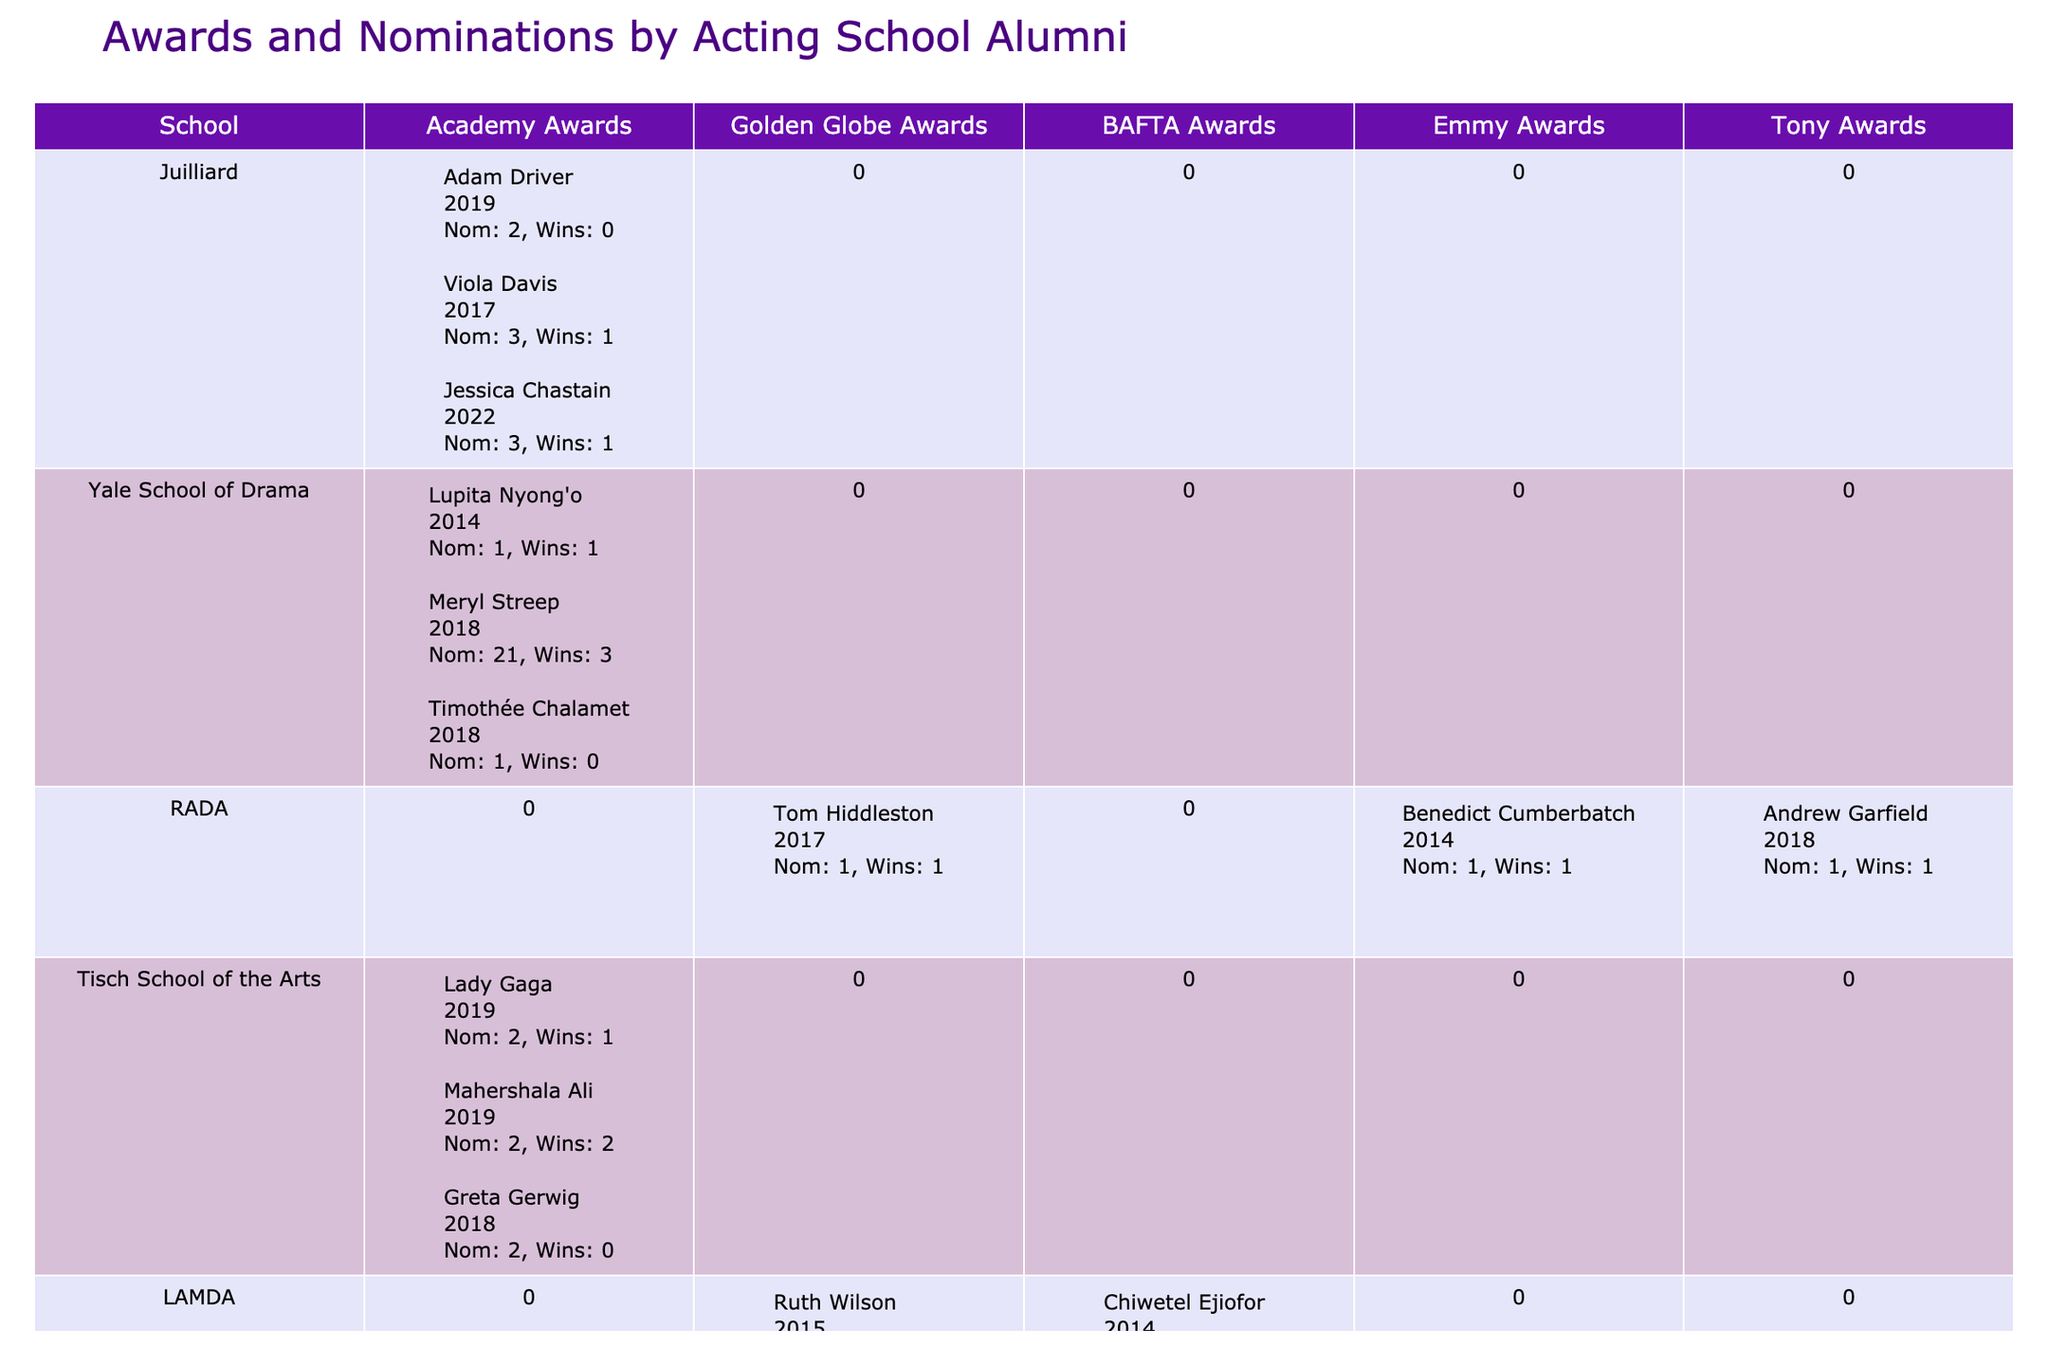What is the total number of Academy Awards won by Juilliard alumni? Juilliard alumni who won Academy Awards are Adam Driver (0 wins), Viola Davis (1 win), and Jessica Chastain (1 win). Adding these gives 0 + 1 + 1 = 2.
Answer: 2 Which acting school has the highest number of nominations for Academy Awards? Yale School of Drama has Meryl Streep with 21 nominations, more than any other alumnus in the table.
Answer: Yale School of Drama Did any alum from LAMDA win an award? Chiwetel Ejiofor was nominated for a BAFTA but had 0 wins, and David Oyelowo had 0 wins at the Golden Globes. Both indicate that no alumnus from LAMDA has won an award.
Answer: No Who received the most nominations for the Emmy Awards from the table? Billy Porter and Benedict Cumberbatch each received 1 nomination for the Emmy Awards. There are no higher nominations listed for other alumni, so the maximum is 1.
Answer: 1 How many total wins did Tisch School of the Arts alumni achieve across all awards? Lady Gaga has 1 win, Mahershala Ali has 2 wins, and Greta Gerwig has 0 wins, giving a total of 1 + 2 + 0 = 3 wins.
Answer: 3 Is it true that all the alumni from RADA won at least one award? RADA alumni are Tom Hiddleston (1 win) and Benedict Cumberbatch (1 win) – both have won awards. Therefore, it is true that all alumni from RADA won at least one award.
Answer: Yes Which school had alumni with nominations in the most different awards categories? Juilliard has alumni nominated for Academy Awards (3), with both competitive results and a nominee for a BAFTA (0 wins). Combining these award categories gives a wider range than other schools.
Answer: Juilliard What is the median number of wins across all alumni in the table? The wins are: Adam Driver (0), Lupita Nyong'o (1), Tom Hiddleston (1), Lady Gaga (1), Chiwetel Ejiofor (0), Billy Porter (1), Viola Davis (1), Meryl Streep (3), Benedict Cumberbatch (1), Mahershala Ali (2), Ruth Wilson (1), Zachary Quinto (0), Jessica Chastain (1), Timothée Chalamet (0), Andrew Garfield (1), Greta Gerwig (0), David Oyelowo (0), Leslie Odom Jr. (1). Sorting these wins gives: 0, 0, 0, 0, 1, 1, 1, 1, 1, 1, 1, 2, 3. The median (middle value) is 1.
Answer: 1 What percentage of nominations did Meryl Streep convert into wins? Meryl Streep has 21 total nominations and 3 wins. The percentage is calculated as (3 wins / 21 nominations) * 100 = 14.29%.
Answer: 14.29% 